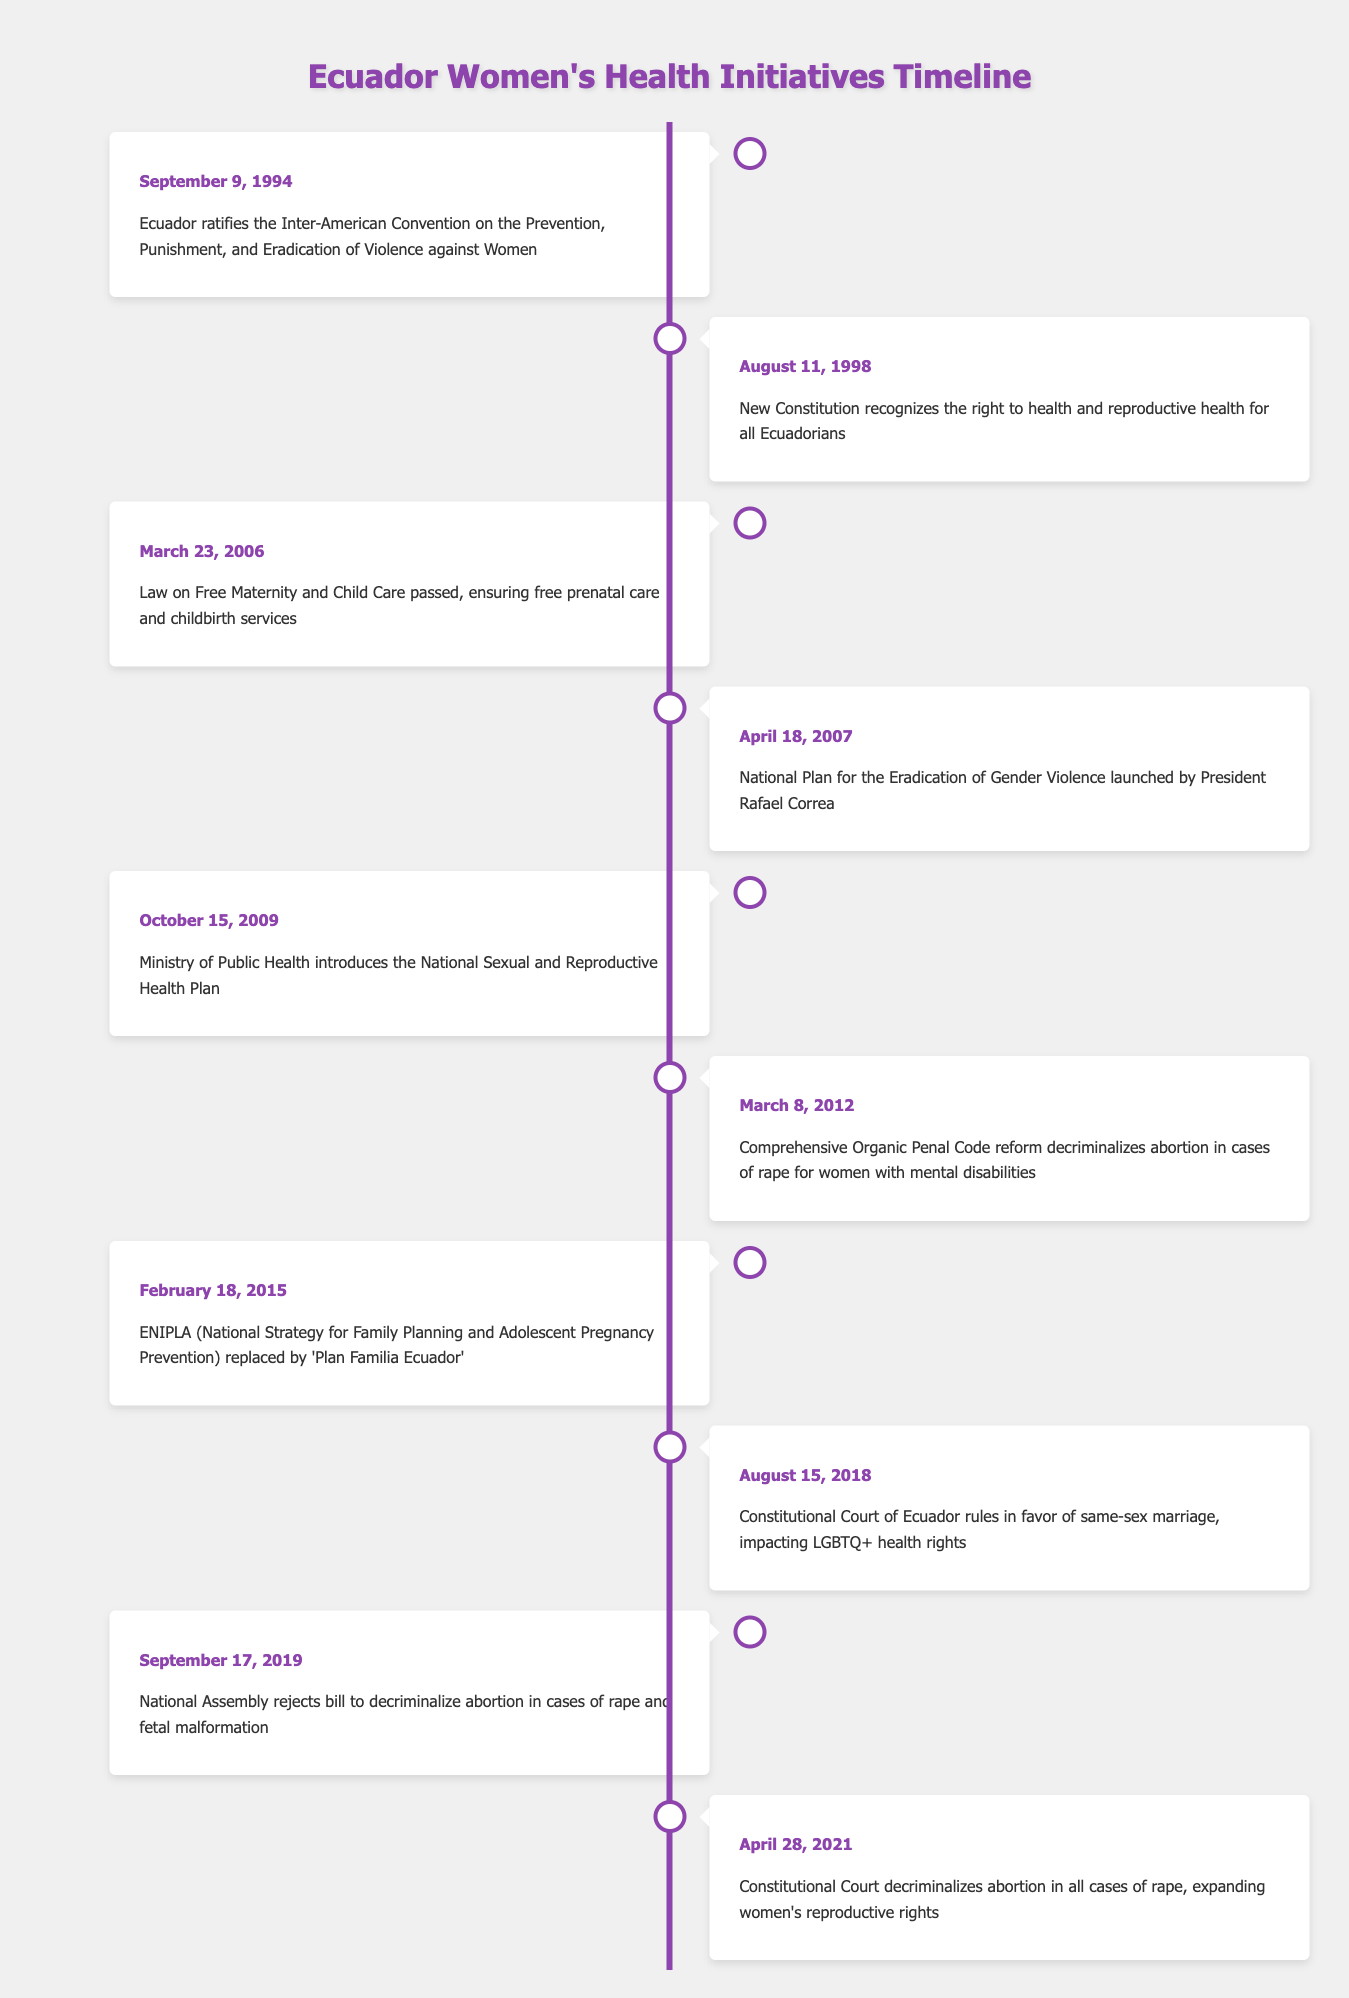What date did Ecuador ratify the Inter-American Convention on the Prevention, Punishment, and Eradication of Violence against Women? The event is listed in the table, showing the date as September 9, 1994.
Answer: September 9, 1994 What law was passed on March 23, 2006? The table indicates that on March 23, 2006, the Law on Free Maternity and Child Care was passed, which ensures free prenatal care and childbirth services.
Answer: Law on Free Maternity and Child Care How many years passed between the recognition of reproductive rights in the Constitution (1998) and the decriminalization of abortion in cases of rape for women with mental disabilities (2012)? From 1998 to 2012 is a span of 14 years. To calculate, 2012 - 1998 = 14.
Answer: 14 years Did Ecuador's Constitutional Court rule in favor of same-sex marriage before or after the launch of the National Plan for the Eradication of Gender Violence? The ruling in favor of same-sex marriage occurred on August 15, 2018, while the National Plan was launched on April 18, 2007. Thus, it occurred after the launch.
Answer: After What is the significance of the event that took place on April 28, 2021? On this date, the Constitutional Court decriminalized abortion in all cases of rape, which significantly expanded women's reproductive rights.
Answer: Expanded women's reproductive rights How many significant events related to women's health initiatives occurred prior to 2010? Referring to the timeline, the events up to 2010 are: 1994, 1998, 2006, and 2007, totaling four significant events.
Answer: 4 events What was the outcome of the National Assembly's vote on September 17, 2019? The National Assembly rejected a bill to decriminalize abortion in cases of rape and fetal malformation on that date, which is explicitly stated in the table.
Answer: Rejected a bill to decriminalize abortion Which event in 2018 impacted LGBTQ+ health rights? The event on August 15, 2018, when the Constitutional Court ruled in favor of same-sex marriage, is noted for its impact on LGBTQ+ health rights.
Answer: Ruling in favor of same-sex marriage 